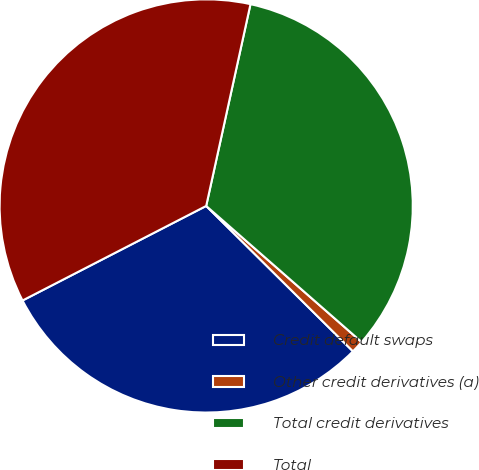Convert chart. <chart><loc_0><loc_0><loc_500><loc_500><pie_chart><fcel>Credit default swaps<fcel>Other credit derivatives (a)<fcel>Total credit derivatives<fcel>Total<nl><fcel>30.01%<fcel>0.98%<fcel>33.01%<fcel>36.01%<nl></chart> 